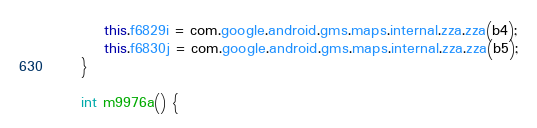Convert code to text. <code><loc_0><loc_0><loc_500><loc_500><_Java_>        this.f6829i = com.google.android.gms.maps.internal.zza.zza(b4);
        this.f6830j = com.google.android.gms.maps.internal.zza.zza(b5);
    }

    int m9976a() {</code> 